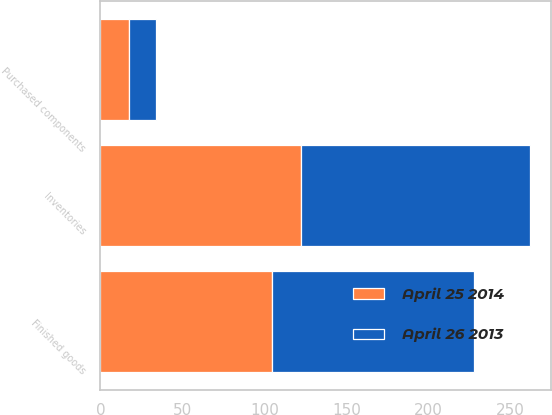Convert chart. <chart><loc_0><loc_0><loc_500><loc_500><stacked_bar_chart><ecel><fcel>Purchased components<fcel>Finished goods<fcel>Inventories<nl><fcel>April 25 2014<fcel>17.6<fcel>104.8<fcel>122.4<nl><fcel>April 26 2013<fcel>16.3<fcel>123.2<fcel>139.5<nl></chart> 